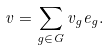Convert formula to latex. <formula><loc_0><loc_0><loc_500><loc_500>v = \sum _ { g \in G } v _ { g } e _ { g } .</formula> 